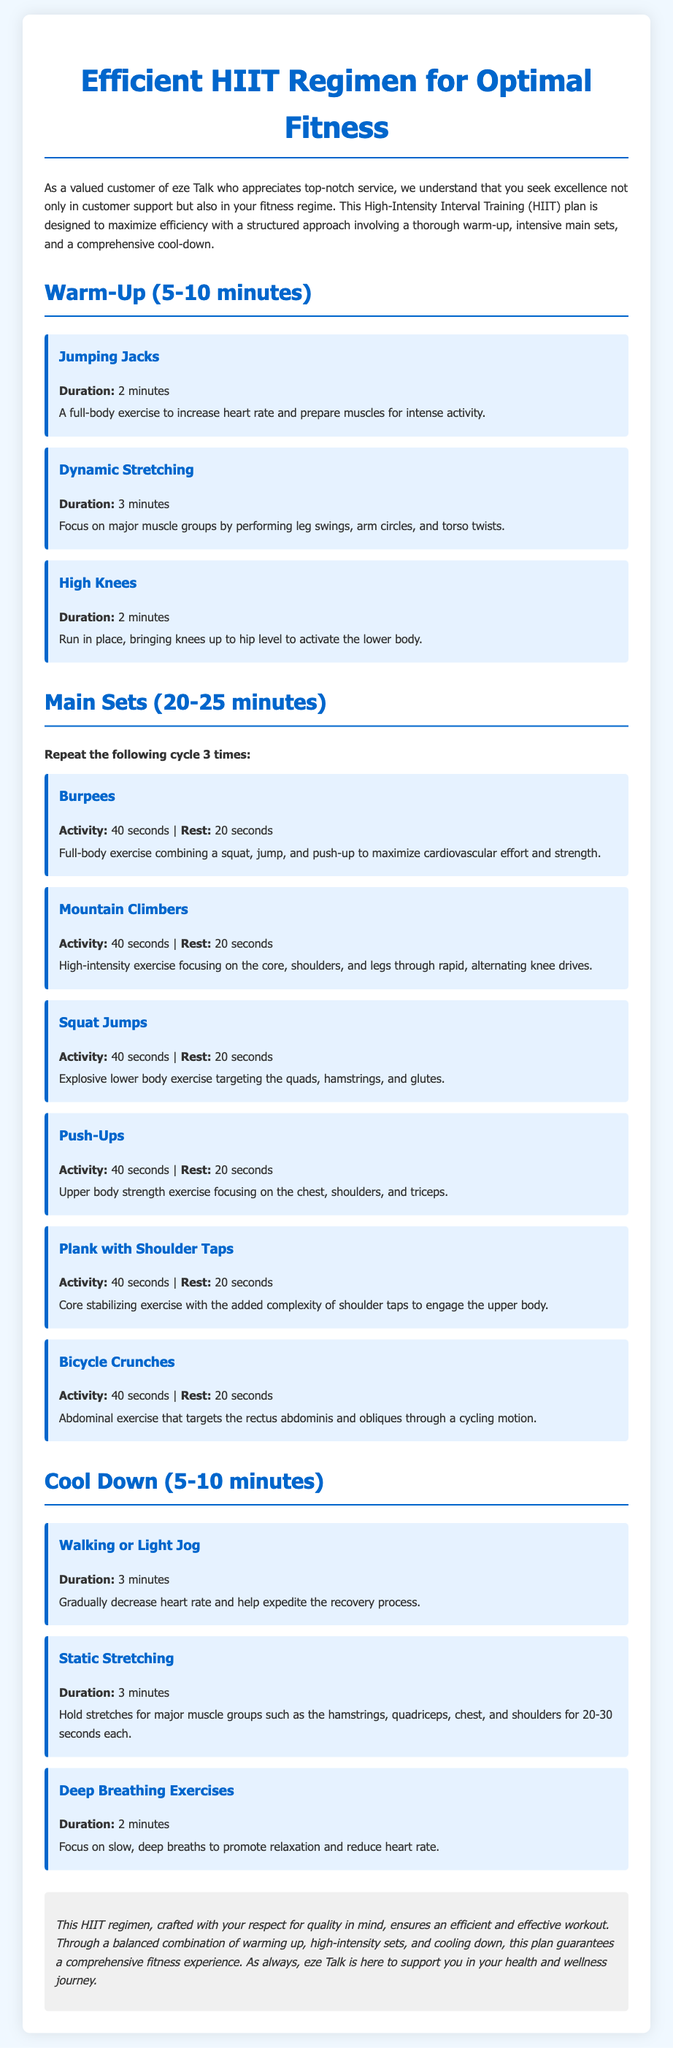What is the duration of the warm-up? The warm-up section specifies a duration of 5-10 minutes.
Answer: 5-10 minutes How many sets are to be repeated in the main workout? The main sets section instructs to repeat the cycle three times.
Answer: 3 times What exercise is performed for 2 minutes during the warm-up? The warm-up section lists Jumping Jacks as an exercise performed for 2 minutes.
Answer: Jumping Jacks What is the activity time for Burpees in the main sets? The main sets detail that Burpees are performed for 40 seconds.
Answer: 40 seconds What exercise focuses on lowering the heart rate during the cool down? The cool down section mentions Walking or Light Jog as a way to decrease heart rate.
Answer: Walking or Light Jog Which exercise in the main sets targets the core and involves knee drives? The main sets describe Mountain Climbers as the exercise targeting the core through knee drives.
Answer: Mountain Climbers What breath technique is used in the cool down for relaxation? The cool down section includes Deep Breathing Exercises focused on relaxation.
Answer: Deep Breathing Exercises What type of workout plan is described in the document? The document specifically outlines a High-Intensity Interval Training (HIIT) workout plan.
Answer: High-Intensity Interval Training (HIIT) 